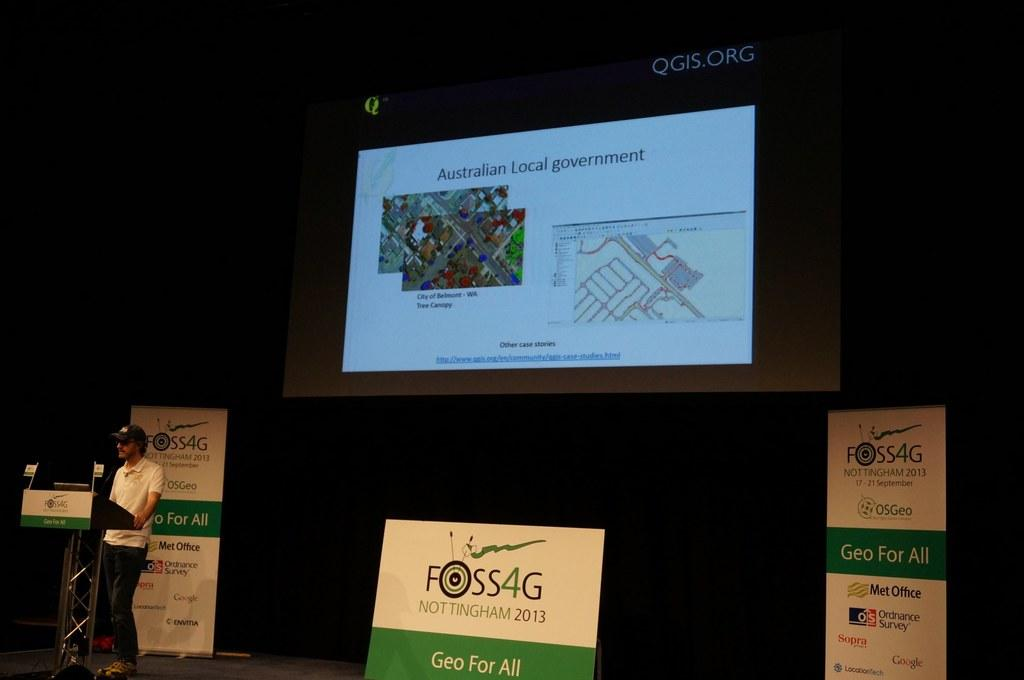Who is present in the image? There is a man in the image. What is the man wearing on his head? The man is wearing a cap. What is the man's position in relation to the podium? The man is standing in front of a podium. What can be seen in the background of the image? There is a projector screen and hoardings visible in the background of the image. What type of activity is the group participating in on the lead? There is no group or lead present in the image; it features a man standing in front of a podium. 